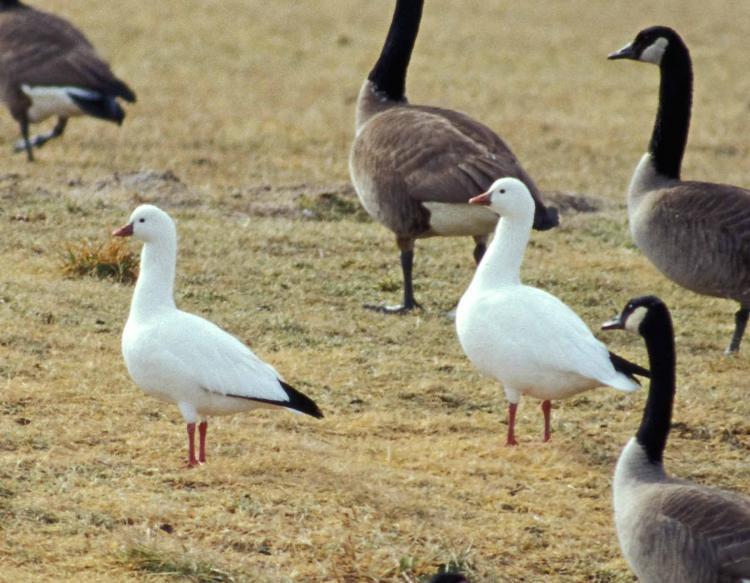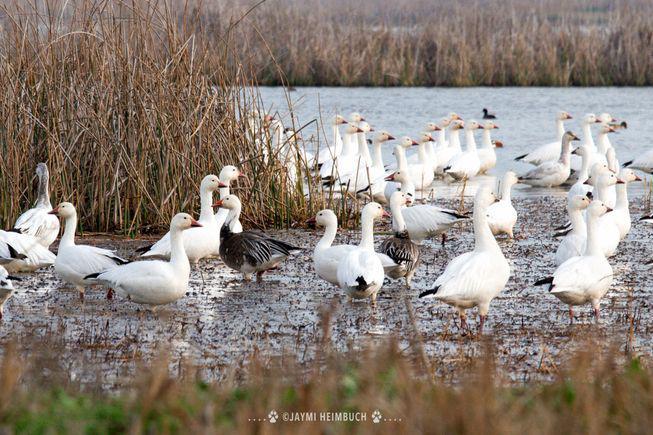The first image is the image on the left, the second image is the image on the right. Analyze the images presented: Is the assertion "The birds in the image on the right are near a body of water." valid? Answer yes or no. Yes. The first image is the image on the left, the second image is the image on the right. Analyze the images presented: Is the assertion "At least one image includes two birds standing face to face on dry land in the foreground." valid? Answer yes or no. No. 